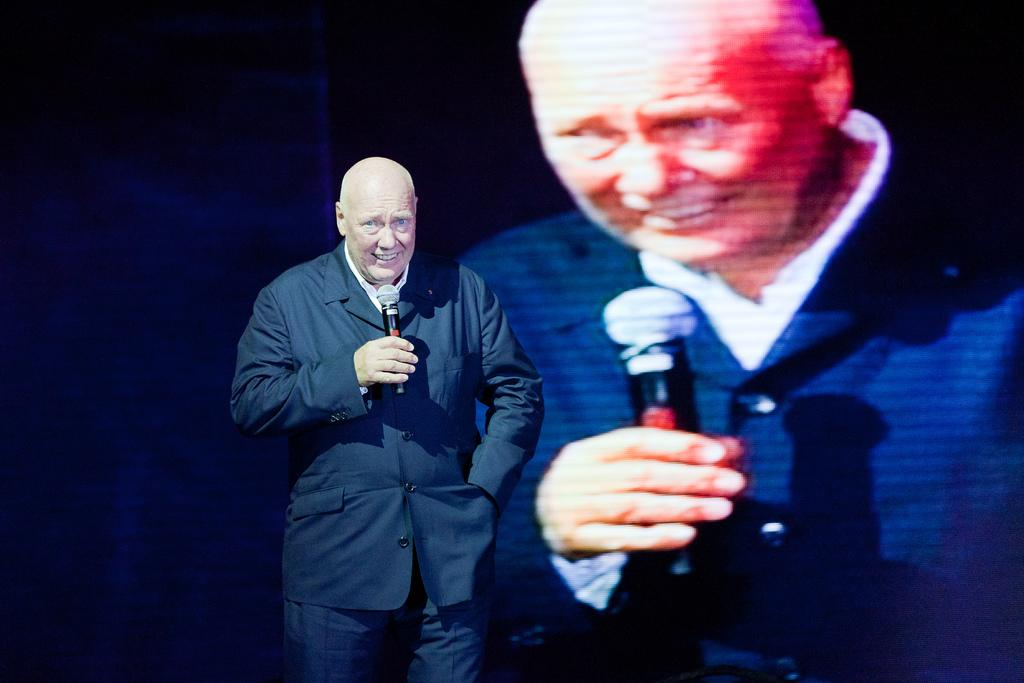What is the main subject of the image? The main subject of the image is a man. What is the man doing in the image? The man is standing and holding a mic in his hand. What is the man wearing in the image? The man is wearing a jacket. What can be seen in the background of the image? There is a screen in the background of the image. What type of ship can be seen in the background of the image? There is no ship present in the image; the background features a screen. What medical procedure is the man performing on the patient in the image? The man is not a doctor, and there is no patient present in the image. 